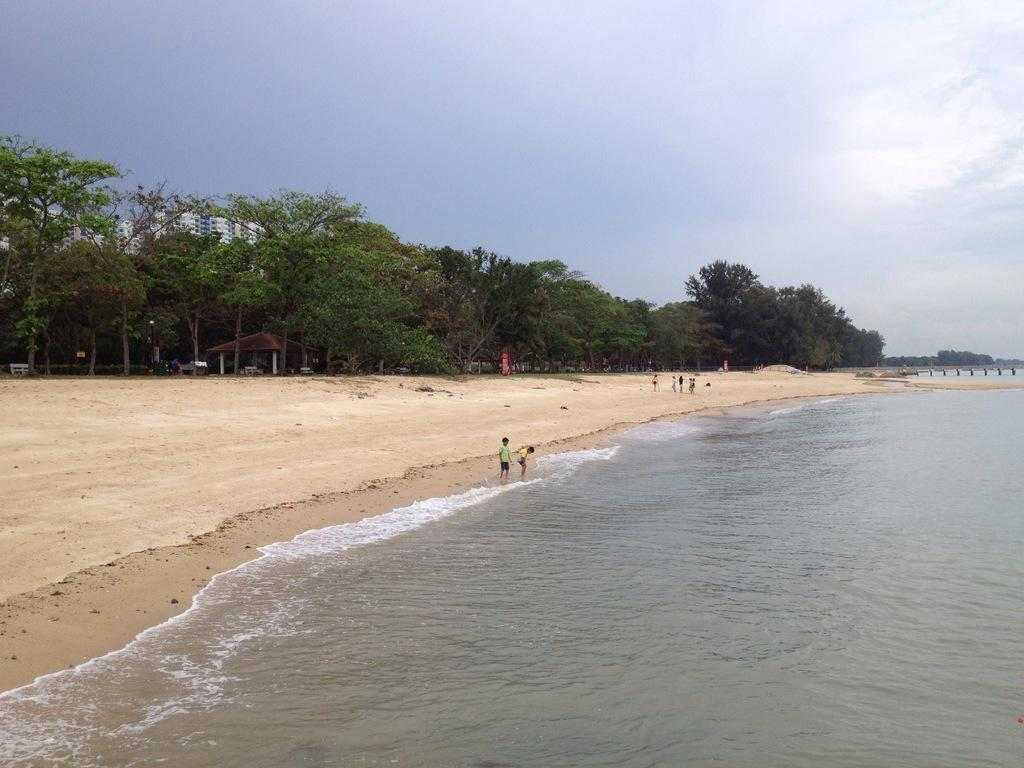What type of natural environment is depicted in the foreground of the image? There is a beach in the foreground of the image. What can be seen on the beach? Water and sand are visible on the beach. What type of vegetation is located near the beach? Trees are located near the beach. What type of man-made structures can be seen near the beach? Buildings are visible near the beach. What is visible in the background of the image? The sky is visible in the image. What type of toothpaste is being used to clean the rod in the image? There is no toothpaste or rod present in the image; it features a beach scene with water, sand, trees, and buildings. 